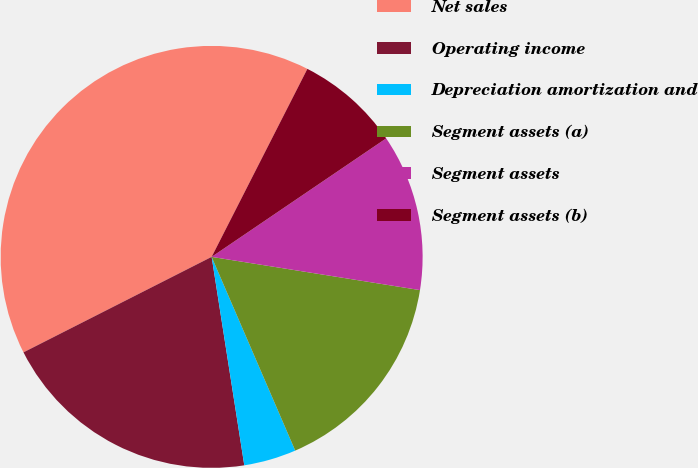Convert chart to OTSL. <chart><loc_0><loc_0><loc_500><loc_500><pie_chart><fcel>Net sales<fcel>Operating income<fcel>Depreciation amortization and<fcel>Segment assets (a)<fcel>Segment assets<fcel>Segment assets (b)<nl><fcel>39.97%<fcel>20.0%<fcel>4.01%<fcel>16.0%<fcel>12.01%<fcel>8.01%<nl></chart> 